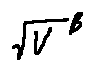<formula> <loc_0><loc_0><loc_500><loc_500>\sqrt { V } ^ { \beta }</formula> 